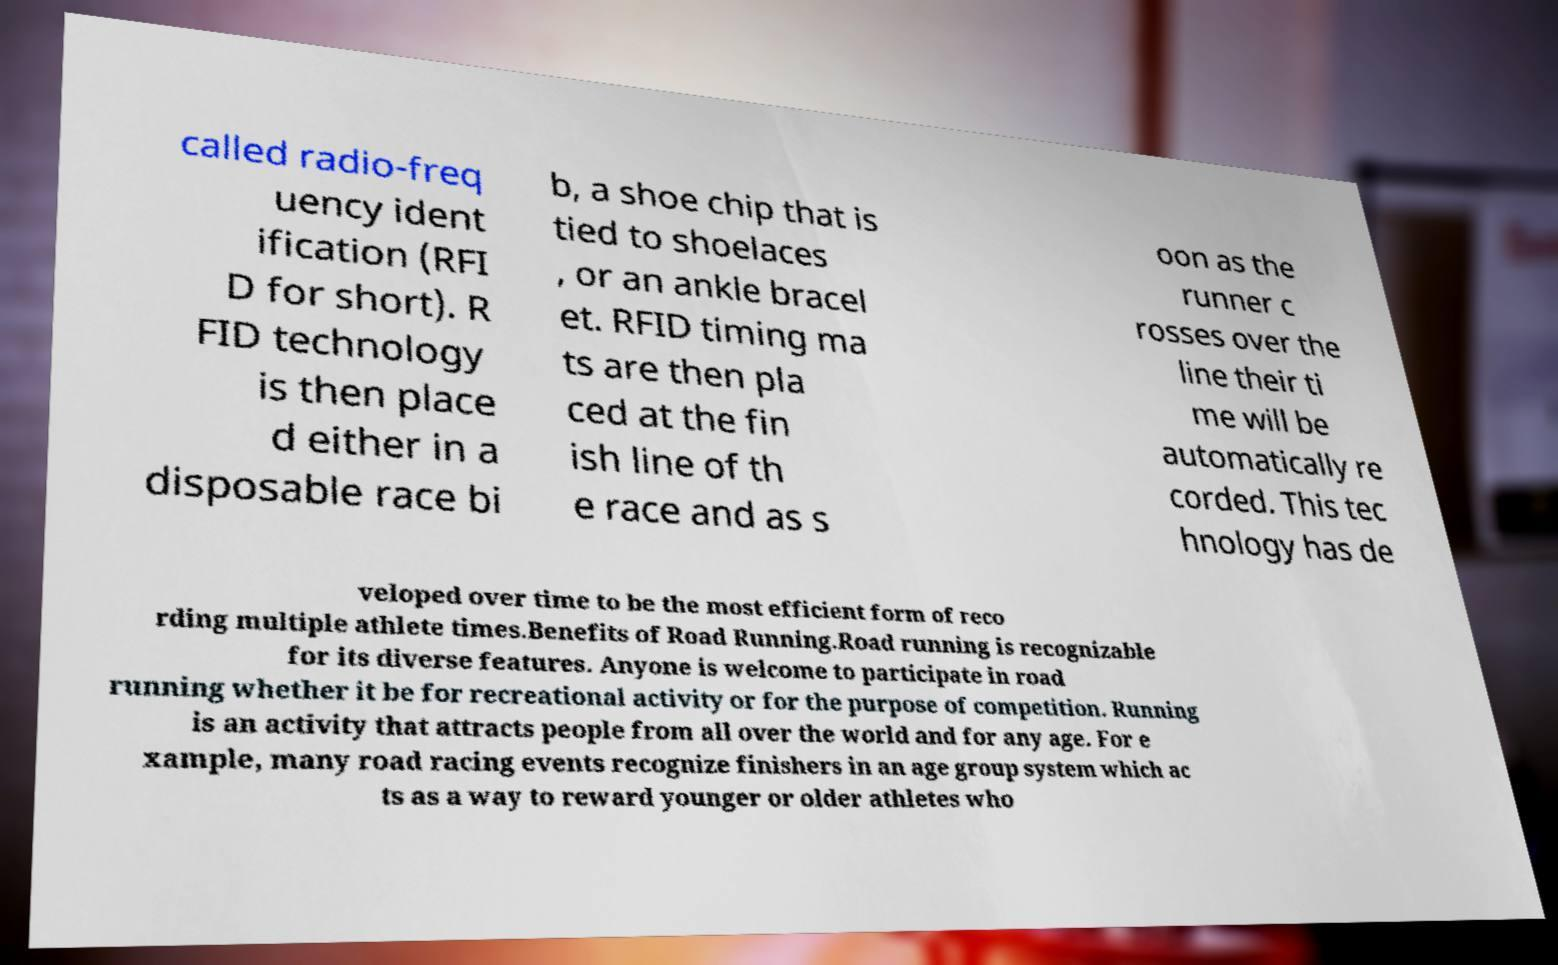Please read and relay the text visible in this image. What does it say? called radio-freq uency ident ification (RFI D for short). R FID technology is then place d either in a disposable race bi b, a shoe chip that is tied to shoelaces , or an ankle bracel et. RFID timing ma ts are then pla ced at the fin ish line of th e race and as s oon as the runner c rosses over the line their ti me will be automatically re corded. This tec hnology has de veloped over time to be the most efficient form of reco rding multiple athlete times.Benefits of Road Running.Road running is recognizable for its diverse features. Anyone is welcome to participate in road running whether it be for recreational activity or for the purpose of competition. Running is an activity that attracts people from all over the world and for any age. For e xample, many road racing events recognize finishers in an age group system which ac ts as a way to reward younger or older athletes who 